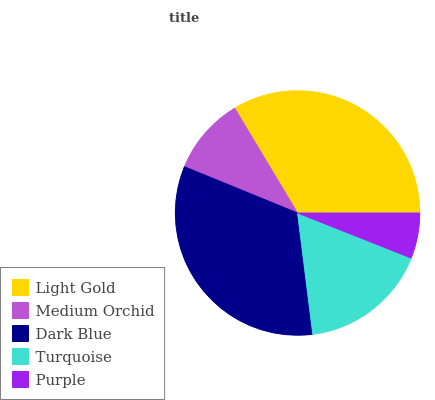Is Purple the minimum?
Answer yes or no. Yes. Is Light Gold the maximum?
Answer yes or no. Yes. Is Medium Orchid the minimum?
Answer yes or no. No. Is Medium Orchid the maximum?
Answer yes or no. No. Is Light Gold greater than Medium Orchid?
Answer yes or no. Yes. Is Medium Orchid less than Light Gold?
Answer yes or no. Yes. Is Medium Orchid greater than Light Gold?
Answer yes or no. No. Is Light Gold less than Medium Orchid?
Answer yes or no. No. Is Turquoise the high median?
Answer yes or no. Yes. Is Turquoise the low median?
Answer yes or no. Yes. Is Dark Blue the high median?
Answer yes or no. No. Is Medium Orchid the low median?
Answer yes or no. No. 